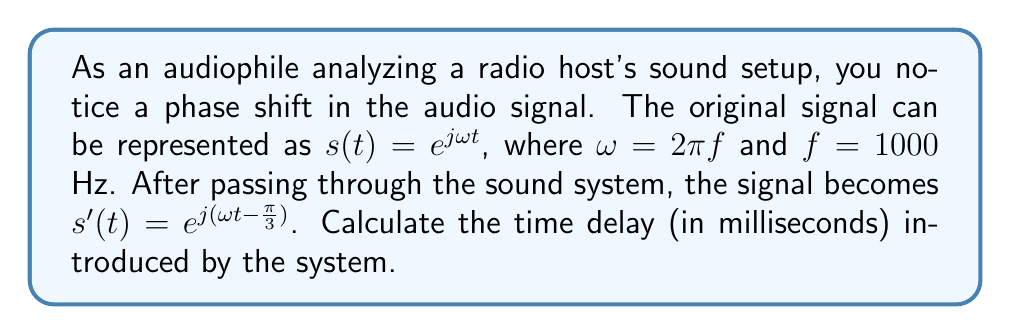Can you solve this math problem? To solve this problem, we need to analyze the phase shift using complex exponentials:

1) The original signal is $s(t) = e^{j\omega t}$
2) The modified signal is $s'(t) = e^{j(\omega t - \frac{\pi}{3})}$

3) The phase shift is represented by $-\frac{\pi}{3}$ in the exponent.

4) We know that $\omega = 2\pi f = 2\pi(1000) = 2000\pi$ rad/s

5) The relationship between phase shift ($\phi$), angular frequency ($\omega$), and time delay ($\tau$) is:

   $\phi = -\omega\tau$

6) In this case, $\phi = -\frac{\pi}{3}$ and $\omega = 2000\pi$

7) Substituting these values:

   $-\frac{\pi}{3} = -2000\pi\tau$

8) Solving for $\tau$:

   $\tau = \frac{\pi/3}{2000\pi} = \frac{1}{6000}$ seconds

9) Converting to milliseconds:

   $\tau = \frac{1}{6000} \times 1000 = \frac{1000}{6000} = \frac{1}{6} \approx 0.1667$ ms

Therefore, the time delay introduced by the system is approximately 0.1667 milliseconds.
Answer: $\frac{1}{6}$ ms or approximately 0.1667 ms 